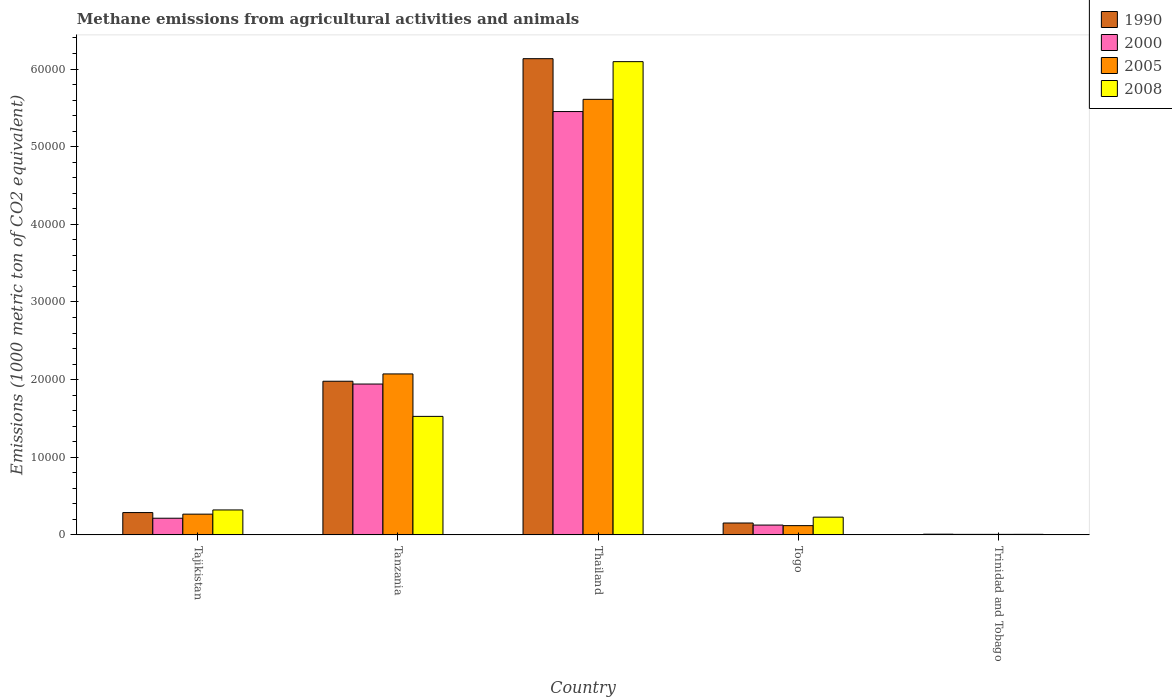Are the number of bars per tick equal to the number of legend labels?
Offer a very short reply. Yes. How many bars are there on the 1st tick from the left?
Provide a short and direct response. 4. How many bars are there on the 4th tick from the right?
Your answer should be compact. 4. What is the label of the 2nd group of bars from the left?
Your answer should be compact. Tanzania. In how many cases, is the number of bars for a given country not equal to the number of legend labels?
Provide a succinct answer. 0. What is the amount of methane emitted in 2005 in Tanzania?
Offer a terse response. 2.07e+04. Across all countries, what is the maximum amount of methane emitted in 2008?
Your response must be concise. 6.10e+04. Across all countries, what is the minimum amount of methane emitted in 2000?
Keep it short and to the point. 68. In which country was the amount of methane emitted in 2000 maximum?
Your answer should be very brief. Thailand. In which country was the amount of methane emitted in 1990 minimum?
Ensure brevity in your answer.  Trinidad and Tobago. What is the total amount of methane emitted in 2008 in the graph?
Offer a very short reply. 8.18e+04. What is the difference between the amount of methane emitted in 2000 in Tanzania and that in Trinidad and Tobago?
Your answer should be compact. 1.94e+04. What is the difference between the amount of methane emitted in 2000 in Tanzania and the amount of methane emitted in 2005 in Thailand?
Offer a very short reply. -3.67e+04. What is the average amount of methane emitted in 1990 per country?
Provide a succinct answer. 1.71e+04. What is the difference between the amount of methane emitted of/in 1990 and amount of methane emitted of/in 2000 in Tajikistan?
Offer a terse response. 727.1. What is the ratio of the amount of methane emitted in 2008 in Togo to that in Trinidad and Tobago?
Your response must be concise. 32.19. Is the amount of methane emitted in 2000 in Tajikistan less than that in Thailand?
Give a very brief answer. Yes. Is the difference between the amount of methane emitted in 1990 in Tajikistan and Thailand greater than the difference between the amount of methane emitted in 2000 in Tajikistan and Thailand?
Your response must be concise. No. What is the difference between the highest and the second highest amount of methane emitted in 2000?
Your answer should be very brief. 1.73e+04. What is the difference between the highest and the lowest amount of methane emitted in 2008?
Ensure brevity in your answer.  6.09e+04. Is the sum of the amount of methane emitted in 2000 in Tajikistan and Trinidad and Tobago greater than the maximum amount of methane emitted in 1990 across all countries?
Your answer should be compact. No. What does the 3rd bar from the left in Togo represents?
Keep it short and to the point. 2005. How many bars are there?
Your response must be concise. 20. What is the difference between two consecutive major ticks on the Y-axis?
Your answer should be very brief. 10000. Are the values on the major ticks of Y-axis written in scientific E-notation?
Offer a terse response. No. Does the graph contain grids?
Ensure brevity in your answer.  No. Where does the legend appear in the graph?
Keep it short and to the point. Top right. How are the legend labels stacked?
Ensure brevity in your answer.  Vertical. What is the title of the graph?
Keep it short and to the point. Methane emissions from agricultural activities and animals. Does "1997" appear as one of the legend labels in the graph?
Provide a succinct answer. No. What is the label or title of the X-axis?
Ensure brevity in your answer.  Country. What is the label or title of the Y-axis?
Ensure brevity in your answer.  Emissions (1000 metric ton of CO2 equivalent). What is the Emissions (1000 metric ton of CO2 equivalent) in 1990 in Tajikistan?
Give a very brief answer. 2874.3. What is the Emissions (1000 metric ton of CO2 equivalent) in 2000 in Tajikistan?
Provide a succinct answer. 2147.2. What is the Emissions (1000 metric ton of CO2 equivalent) in 2005 in Tajikistan?
Offer a terse response. 2672.7. What is the Emissions (1000 metric ton of CO2 equivalent) in 2008 in Tajikistan?
Make the answer very short. 3214.1. What is the Emissions (1000 metric ton of CO2 equivalent) of 1990 in Tanzania?
Keep it short and to the point. 1.98e+04. What is the Emissions (1000 metric ton of CO2 equivalent) in 2000 in Tanzania?
Give a very brief answer. 1.94e+04. What is the Emissions (1000 metric ton of CO2 equivalent) in 2005 in Tanzania?
Make the answer very short. 2.07e+04. What is the Emissions (1000 metric ton of CO2 equivalent) in 2008 in Tanzania?
Offer a very short reply. 1.53e+04. What is the Emissions (1000 metric ton of CO2 equivalent) of 1990 in Thailand?
Give a very brief answer. 6.13e+04. What is the Emissions (1000 metric ton of CO2 equivalent) of 2000 in Thailand?
Your answer should be very brief. 5.45e+04. What is the Emissions (1000 metric ton of CO2 equivalent) in 2005 in Thailand?
Give a very brief answer. 5.61e+04. What is the Emissions (1000 metric ton of CO2 equivalent) in 2008 in Thailand?
Give a very brief answer. 6.10e+04. What is the Emissions (1000 metric ton of CO2 equivalent) of 1990 in Togo?
Give a very brief answer. 1531.1. What is the Emissions (1000 metric ton of CO2 equivalent) in 2000 in Togo?
Keep it short and to the point. 1266.2. What is the Emissions (1000 metric ton of CO2 equivalent) in 2005 in Togo?
Your response must be concise. 1193.3. What is the Emissions (1000 metric ton of CO2 equivalent) in 2008 in Togo?
Give a very brief answer. 2285.6. What is the Emissions (1000 metric ton of CO2 equivalent) of 1990 in Trinidad and Tobago?
Your response must be concise. 92.7. What is the Emissions (1000 metric ton of CO2 equivalent) of 2000 in Trinidad and Tobago?
Provide a succinct answer. 68. What is the Emissions (1000 metric ton of CO2 equivalent) of 2005 in Trinidad and Tobago?
Your response must be concise. 68.1. Across all countries, what is the maximum Emissions (1000 metric ton of CO2 equivalent) of 1990?
Make the answer very short. 6.13e+04. Across all countries, what is the maximum Emissions (1000 metric ton of CO2 equivalent) in 2000?
Ensure brevity in your answer.  5.45e+04. Across all countries, what is the maximum Emissions (1000 metric ton of CO2 equivalent) of 2005?
Provide a short and direct response. 5.61e+04. Across all countries, what is the maximum Emissions (1000 metric ton of CO2 equivalent) of 2008?
Ensure brevity in your answer.  6.10e+04. Across all countries, what is the minimum Emissions (1000 metric ton of CO2 equivalent) in 1990?
Make the answer very short. 92.7. Across all countries, what is the minimum Emissions (1000 metric ton of CO2 equivalent) in 2000?
Your answer should be compact. 68. Across all countries, what is the minimum Emissions (1000 metric ton of CO2 equivalent) of 2005?
Provide a short and direct response. 68.1. What is the total Emissions (1000 metric ton of CO2 equivalent) in 1990 in the graph?
Ensure brevity in your answer.  8.56e+04. What is the total Emissions (1000 metric ton of CO2 equivalent) in 2000 in the graph?
Offer a terse response. 7.74e+04. What is the total Emissions (1000 metric ton of CO2 equivalent) of 2005 in the graph?
Ensure brevity in your answer.  8.08e+04. What is the total Emissions (1000 metric ton of CO2 equivalent) in 2008 in the graph?
Keep it short and to the point. 8.18e+04. What is the difference between the Emissions (1000 metric ton of CO2 equivalent) in 1990 in Tajikistan and that in Tanzania?
Make the answer very short. -1.69e+04. What is the difference between the Emissions (1000 metric ton of CO2 equivalent) in 2000 in Tajikistan and that in Tanzania?
Ensure brevity in your answer.  -1.73e+04. What is the difference between the Emissions (1000 metric ton of CO2 equivalent) in 2005 in Tajikistan and that in Tanzania?
Your response must be concise. -1.81e+04. What is the difference between the Emissions (1000 metric ton of CO2 equivalent) in 2008 in Tajikistan and that in Tanzania?
Your answer should be compact. -1.20e+04. What is the difference between the Emissions (1000 metric ton of CO2 equivalent) of 1990 in Tajikistan and that in Thailand?
Give a very brief answer. -5.85e+04. What is the difference between the Emissions (1000 metric ton of CO2 equivalent) of 2000 in Tajikistan and that in Thailand?
Ensure brevity in your answer.  -5.24e+04. What is the difference between the Emissions (1000 metric ton of CO2 equivalent) of 2005 in Tajikistan and that in Thailand?
Provide a succinct answer. -5.34e+04. What is the difference between the Emissions (1000 metric ton of CO2 equivalent) of 2008 in Tajikistan and that in Thailand?
Give a very brief answer. -5.77e+04. What is the difference between the Emissions (1000 metric ton of CO2 equivalent) of 1990 in Tajikistan and that in Togo?
Offer a terse response. 1343.2. What is the difference between the Emissions (1000 metric ton of CO2 equivalent) in 2000 in Tajikistan and that in Togo?
Your answer should be compact. 881. What is the difference between the Emissions (1000 metric ton of CO2 equivalent) of 2005 in Tajikistan and that in Togo?
Offer a very short reply. 1479.4. What is the difference between the Emissions (1000 metric ton of CO2 equivalent) of 2008 in Tajikistan and that in Togo?
Offer a very short reply. 928.5. What is the difference between the Emissions (1000 metric ton of CO2 equivalent) of 1990 in Tajikistan and that in Trinidad and Tobago?
Offer a terse response. 2781.6. What is the difference between the Emissions (1000 metric ton of CO2 equivalent) of 2000 in Tajikistan and that in Trinidad and Tobago?
Your answer should be very brief. 2079.2. What is the difference between the Emissions (1000 metric ton of CO2 equivalent) in 2005 in Tajikistan and that in Trinidad and Tobago?
Your response must be concise. 2604.6. What is the difference between the Emissions (1000 metric ton of CO2 equivalent) of 2008 in Tajikistan and that in Trinidad and Tobago?
Your response must be concise. 3143.1. What is the difference between the Emissions (1000 metric ton of CO2 equivalent) of 1990 in Tanzania and that in Thailand?
Provide a short and direct response. -4.15e+04. What is the difference between the Emissions (1000 metric ton of CO2 equivalent) in 2000 in Tanzania and that in Thailand?
Your response must be concise. -3.51e+04. What is the difference between the Emissions (1000 metric ton of CO2 equivalent) of 2005 in Tanzania and that in Thailand?
Your answer should be compact. -3.54e+04. What is the difference between the Emissions (1000 metric ton of CO2 equivalent) of 2008 in Tanzania and that in Thailand?
Ensure brevity in your answer.  -4.57e+04. What is the difference between the Emissions (1000 metric ton of CO2 equivalent) of 1990 in Tanzania and that in Togo?
Give a very brief answer. 1.83e+04. What is the difference between the Emissions (1000 metric ton of CO2 equivalent) of 2000 in Tanzania and that in Togo?
Your answer should be very brief. 1.82e+04. What is the difference between the Emissions (1000 metric ton of CO2 equivalent) in 2005 in Tanzania and that in Togo?
Your answer should be very brief. 1.95e+04. What is the difference between the Emissions (1000 metric ton of CO2 equivalent) of 2008 in Tanzania and that in Togo?
Keep it short and to the point. 1.30e+04. What is the difference between the Emissions (1000 metric ton of CO2 equivalent) of 1990 in Tanzania and that in Trinidad and Tobago?
Your response must be concise. 1.97e+04. What is the difference between the Emissions (1000 metric ton of CO2 equivalent) in 2000 in Tanzania and that in Trinidad and Tobago?
Keep it short and to the point. 1.94e+04. What is the difference between the Emissions (1000 metric ton of CO2 equivalent) in 2005 in Tanzania and that in Trinidad and Tobago?
Offer a terse response. 2.07e+04. What is the difference between the Emissions (1000 metric ton of CO2 equivalent) of 2008 in Tanzania and that in Trinidad and Tobago?
Offer a terse response. 1.52e+04. What is the difference between the Emissions (1000 metric ton of CO2 equivalent) in 1990 in Thailand and that in Togo?
Provide a short and direct response. 5.98e+04. What is the difference between the Emissions (1000 metric ton of CO2 equivalent) of 2000 in Thailand and that in Togo?
Provide a succinct answer. 5.33e+04. What is the difference between the Emissions (1000 metric ton of CO2 equivalent) in 2005 in Thailand and that in Togo?
Provide a succinct answer. 5.49e+04. What is the difference between the Emissions (1000 metric ton of CO2 equivalent) of 2008 in Thailand and that in Togo?
Make the answer very short. 5.87e+04. What is the difference between the Emissions (1000 metric ton of CO2 equivalent) of 1990 in Thailand and that in Trinidad and Tobago?
Provide a short and direct response. 6.12e+04. What is the difference between the Emissions (1000 metric ton of CO2 equivalent) of 2000 in Thailand and that in Trinidad and Tobago?
Provide a succinct answer. 5.45e+04. What is the difference between the Emissions (1000 metric ton of CO2 equivalent) in 2005 in Thailand and that in Trinidad and Tobago?
Provide a short and direct response. 5.60e+04. What is the difference between the Emissions (1000 metric ton of CO2 equivalent) in 2008 in Thailand and that in Trinidad and Tobago?
Your answer should be very brief. 6.09e+04. What is the difference between the Emissions (1000 metric ton of CO2 equivalent) of 1990 in Togo and that in Trinidad and Tobago?
Your response must be concise. 1438.4. What is the difference between the Emissions (1000 metric ton of CO2 equivalent) in 2000 in Togo and that in Trinidad and Tobago?
Keep it short and to the point. 1198.2. What is the difference between the Emissions (1000 metric ton of CO2 equivalent) of 2005 in Togo and that in Trinidad and Tobago?
Offer a very short reply. 1125.2. What is the difference between the Emissions (1000 metric ton of CO2 equivalent) of 2008 in Togo and that in Trinidad and Tobago?
Your answer should be very brief. 2214.6. What is the difference between the Emissions (1000 metric ton of CO2 equivalent) of 1990 in Tajikistan and the Emissions (1000 metric ton of CO2 equivalent) of 2000 in Tanzania?
Your answer should be very brief. -1.66e+04. What is the difference between the Emissions (1000 metric ton of CO2 equivalent) in 1990 in Tajikistan and the Emissions (1000 metric ton of CO2 equivalent) in 2005 in Tanzania?
Provide a short and direct response. -1.79e+04. What is the difference between the Emissions (1000 metric ton of CO2 equivalent) in 1990 in Tajikistan and the Emissions (1000 metric ton of CO2 equivalent) in 2008 in Tanzania?
Your answer should be very brief. -1.24e+04. What is the difference between the Emissions (1000 metric ton of CO2 equivalent) of 2000 in Tajikistan and the Emissions (1000 metric ton of CO2 equivalent) of 2005 in Tanzania?
Your response must be concise. -1.86e+04. What is the difference between the Emissions (1000 metric ton of CO2 equivalent) of 2000 in Tajikistan and the Emissions (1000 metric ton of CO2 equivalent) of 2008 in Tanzania?
Ensure brevity in your answer.  -1.31e+04. What is the difference between the Emissions (1000 metric ton of CO2 equivalent) in 2005 in Tajikistan and the Emissions (1000 metric ton of CO2 equivalent) in 2008 in Tanzania?
Keep it short and to the point. -1.26e+04. What is the difference between the Emissions (1000 metric ton of CO2 equivalent) in 1990 in Tajikistan and the Emissions (1000 metric ton of CO2 equivalent) in 2000 in Thailand?
Give a very brief answer. -5.17e+04. What is the difference between the Emissions (1000 metric ton of CO2 equivalent) of 1990 in Tajikistan and the Emissions (1000 metric ton of CO2 equivalent) of 2005 in Thailand?
Your answer should be very brief. -5.32e+04. What is the difference between the Emissions (1000 metric ton of CO2 equivalent) of 1990 in Tajikistan and the Emissions (1000 metric ton of CO2 equivalent) of 2008 in Thailand?
Provide a succinct answer. -5.81e+04. What is the difference between the Emissions (1000 metric ton of CO2 equivalent) in 2000 in Tajikistan and the Emissions (1000 metric ton of CO2 equivalent) in 2005 in Thailand?
Give a very brief answer. -5.40e+04. What is the difference between the Emissions (1000 metric ton of CO2 equivalent) of 2000 in Tajikistan and the Emissions (1000 metric ton of CO2 equivalent) of 2008 in Thailand?
Offer a very short reply. -5.88e+04. What is the difference between the Emissions (1000 metric ton of CO2 equivalent) of 2005 in Tajikistan and the Emissions (1000 metric ton of CO2 equivalent) of 2008 in Thailand?
Ensure brevity in your answer.  -5.83e+04. What is the difference between the Emissions (1000 metric ton of CO2 equivalent) of 1990 in Tajikistan and the Emissions (1000 metric ton of CO2 equivalent) of 2000 in Togo?
Keep it short and to the point. 1608.1. What is the difference between the Emissions (1000 metric ton of CO2 equivalent) of 1990 in Tajikistan and the Emissions (1000 metric ton of CO2 equivalent) of 2005 in Togo?
Give a very brief answer. 1681. What is the difference between the Emissions (1000 metric ton of CO2 equivalent) of 1990 in Tajikistan and the Emissions (1000 metric ton of CO2 equivalent) of 2008 in Togo?
Offer a very short reply. 588.7. What is the difference between the Emissions (1000 metric ton of CO2 equivalent) in 2000 in Tajikistan and the Emissions (1000 metric ton of CO2 equivalent) in 2005 in Togo?
Make the answer very short. 953.9. What is the difference between the Emissions (1000 metric ton of CO2 equivalent) in 2000 in Tajikistan and the Emissions (1000 metric ton of CO2 equivalent) in 2008 in Togo?
Keep it short and to the point. -138.4. What is the difference between the Emissions (1000 metric ton of CO2 equivalent) of 2005 in Tajikistan and the Emissions (1000 metric ton of CO2 equivalent) of 2008 in Togo?
Provide a short and direct response. 387.1. What is the difference between the Emissions (1000 metric ton of CO2 equivalent) in 1990 in Tajikistan and the Emissions (1000 metric ton of CO2 equivalent) in 2000 in Trinidad and Tobago?
Make the answer very short. 2806.3. What is the difference between the Emissions (1000 metric ton of CO2 equivalent) of 1990 in Tajikistan and the Emissions (1000 metric ton of CO2 equivalent) of 2005 in Trinidad and Tobago?
Your answer should be very brief. 2806.2. What is the difference between the Emissions (1000 metric ton of CO2 equivalent) in 1990 in Tajikistan and the Emissions (1000 metric ton of CO2 equivalent) in 2008 in Trinidad and Tobago?
Make the answer very short. 2803.3. What is the difference between the Emissions (1000 metric ton of CO2 equivalent) in 2000 in Tajikistan and the Emissions (1000 metric ton of CO2 equivalent) in 2005 in Trinidad and Tobago?
Offer a very short reply. 2079.1. What is the difference between the Emissions (1000 metric ton of CO2 equivalent) of 2000 in Tajikistan and the Emissions (1000 metric ton of CO2 equivalent) of 2008 in Trinidad and Tobago?
Your answer should be very brief. 2076.2. What is the difference between the Emissions (1000 metric ton of CO2 equivalent) in 2005 in Tajikistan and the Emissions (1000 metric ton of CO2 equivalent) in 2008 in Trinidad and Tobago?
Keep it short and to the point. 2601.7. What is the difference between the Emissions (1000 metric ton of CO2 equivalent) in 1990 in Tanzania and the Emissions (1000 metric ton of CO2 equivalent) in 2000 in Thailand?
Give a very brief answer. -3.47e+04. What is the difference between the Emissions (1000 metric ton of CO2 equivalent) of 1990 in Tanzania and the Emissions (1000 metric ton of CO2 equivalent) of 2005 in Thailand?
Your response must be concise. -3.63e+04. What is the difference between the Emissions (1000 metric ton of CO2 equivalent) in 1990 in Tanzania and the Emissions (1000 metric ton of CO2 equivalent) in 2008 in Thailand?
Your answer should be very brief. -4.12e+04. What is the difference between the Emissions (1000 metric ton of CO2 equivalent) of 2000 in Tanzania and the Emissions (1000 metric ton of CO2 equivalent) of 2005 in Thailand?
Your answer should be compact. -3.67e+04. What is the difference between the Emissions (1000 metric ton of CO2 equivalent) of 2000 in Tanzania and the Emissions (1000 metric ton of CO2 equivalent) of 2008 in Thailand?
Your answer should be very brief. -4.15e+04. What is the difference between the Emissions (1000 metric ton of CO2 equivalent) of 2005 in Tanzania and the Emissions (1000 metric ton of CO2 equivalent) of 2008 in Thailand?
Provide a succinct answer. -4.02e+04. What is the difference between the Emissions (1000 metric ton of CO2 equivalent) of 1990 in Tanzania and the Emissions (1000 metric ton of CO2 equivalent) of 2000 in Togo?
Provide a succinct answer. 1.85e+04. What is the difference between the Emissions (1000 metric ton of CO2 equivalent) of 1990 in Tanzania and the Emissions (1000 metric ton of CO2 equivalent) of 2005 in Togo?
Your answer should be very brief. 1.86e+04. What is the difference between the Emissions (1000 metric ton of CO2 equivalent) in 1990 in Tanzania and the Emissions (1000 metric ton of CO2 equivalent) in 2008 in Togo?
Offer a very short reply. 1.75e+04. What is the difference between the Emissions (1000 metric ton of CO2 equivalent) of 2000 in Tanzania and the Emissions (1000 metric ton of CO2 equivalent) of 2005 in Togo?
Offer a terse response. 1.82e+04. What is the difference between the Emissions (1000 metric ton of CO2 equivalent) in 2000 in Tanzania and the Emissions (1000 metric ton of CO2 equivalent) in 2008 in Togo?
Offer a very short reply. 1.71e+04. What is the difference between the Emissions (1000 metric ton of CO2 equivalent) in 2005 in Tanzania and the Emissions (1000 metric ton of CO2 equivalent) in 2008 in Togo?
Offer a very short reply. 1.84e+04. What is the difference between the Emissions (1000 metric ton of CO2 equivalent) of 1990 in Tanzania and the Emissions (1000 metric ton of CO2 equivalent) of 2000 in Trinidad and Tobago?
Offer a very short reply. 1.97e+04. What is the difference between the Emissions (1000 metric ton of CO2 equivalent) in 1990 in Tanzania and the Emissions (1000 metric ton of CO2 equivalent) in 2005 in Trinidad and Tobago?
Your answer should be compact. 1.97e+04. What is the difference between the Emissions (1000 metric ton of CO2 equivalent) in 1990 in Tanzania and the Emissions (1000 metric ton of CO2 equivalent) in 2008 in Trinidad and Tobago?
Your answer should be very brief. 1.97e+04. What is the difference between the Emissions (1000 metric ton of CO2 equivalent) in 2000 in Tanzania and the Emissions (1000 metric ton of CO2 equivalent) in 2005 in Trinidad and Tobago?
Your response must be concise. 1.94e+04. What is the difference between the Emissions (1000 metric ton of CO2 equivalent) in 2000 in Tanzania and the Emissions (1000 metric ton of CO2 equivalent) in 2008 in Trinidad and Tobago?
Make the answer very short. 1.94e+04. What is the difference between the Emissions (1000 metric ton of CO2 equivalent) in 2005 in Tanzania and the Emissions (1000 metric ton of CO2 equivalent) in 2008 in Trinidad and Tobago?
Give a very brief answer. 2.07e+04. What is the difference between the Emissions (1000 metric ton of CO2 equivalent) of 1990 in Thailand and the Emissions (1000 metric ton of CO2 equivalent) of 2000 in Togo?
Provide a short and direct response. 6.01e+04. What is the difference between the Emissions (1000 metric ton of CO2 equivalent) in 1990 in Thailand and the Emissions (1000 metric ton of CO2 equivalent) in 2005 in Togo?
Provide a short and direct response. 6.01e+04. What is the difference between the Emissions (1000 metric ton of CO2 equivalent) of 1990 in Thailand and the Emissions (1000 metric ton of CO2 equivalent) of 2008 in Togo?
Your answer should be compact. 5.90e+04. What is the difference between the Emissions (1000 metric ton of CO2 equivalent) in 2000 in Thailand and the Emissions (1000 metric ton of CO2 equivalent) in 2005 in Togo?
Your answer should be very brief. 5.33e+04. What is the difference between the Emissions (1000 metric ton of CO2 equivalent) of 2000 in Thailand and the Emissions (1000 metric ton of CO2 equivalent) of 2008 in Togo?
Provide a short and direct response. 5.22e+04. What is the difference between the Emissions (1000 metric ton of CO2 equivalent) in 2005 in Thailand and the Emissions (1000 metric ton of CO2 equivalent) in 2008 in Togo?
Ensure brevity in your answer.  5.38e+04. What is the difference between the Emissions (1000 metric ton of CO2 equivalent) of 1990 in Thailand and the Emissions (1000 metric ton of CO2 equivalent) of 2000 in Trinidad and Tobago?
Your response must be concise. 6.13e+04. What is the difference between the Emissions (1000 metric ton of CO2 equivalent) of 1990 in Thailand and the Emissions (1000 metric ton of CO2 equivalent) of 2005 in Trinidad and Tobago?
Provide a short and direct response. 6.13e+04. What is the difference between the Emissions (1000 metric ton of CO2 equivalent) in 1990 in Thailand and the Emissions (1000 metric ton of CO2 equivalent) in 2008 in Trinidad and Tobago?
Your answer should be compact. 6.13e+04. What is the difference between the Emissions (1000 metric ton of CO2 equivalent) in 2000 in Thailand and the Emissions (1000 metric ton of CO2 equivalent) in 2005 in Trinidad and Tobago?
Provide a succinct answer. 5.45e+04. What is the difference between the Emissions (1000 metric ton of CO2 equivalent) of 2000 in Thailand and the Emissions (1000 metric ton of CO2 equivalent) of 2008 in Trinidad and Tobago?
Offer a terse response. 5.45e+04. What is the difference between the Emissions (1000 metric ton of CO2 equivalent) in 2005 in Thailand and the Emissions (1000 metric ton of CO2 equivalent) in 2008 in Trinidad and Tobago?
Provide a succinct answer. 5.60e+04. What is the difference between the Emissions (1000 metric ton of CO2 equivalent) of 1990 in Togo and the Emissions (1000 metric ton of CO2 equivalent) of 2000 in Trinidad and Tobago?
Ensure brevity in your answer.  1463.1. What is the difference between the Emissions (1000 metric ton of CO2 equivalent) of 1990 in Togo and the Emissions (1000 metric ton of CO2 equivalent) of 2005 in Trinidad and Tobago?
Give a very brief answer. 1463. What is the difference between the Emissions (1000 metric ton of CO2 equivalent) in 1990 in Togo and the Emissions (1000 metric ton of CO2 equivalent) in 2008 in Trinidad and Tobago?
Your answer should be compact. 1460.1. What is the difference between the Emissions (1000 metric ton of CO2 equivalent) of 2000 in Togo and the Emissions (1000 metric ton of CO2 equivalent) of 2005 in Trinidad and Tobago?
Offer a very short reply. 1198.1. What is the difference between the Emissions (1000 metric ton of CO2 equivalent) in 2000 in Togo and the Emissions (1000 metric ton of CO2 equivalent) in 2008 in Trinidad and Tobago?
Give a very brief answer. 1195.2. What is the difference between the Emissions (1000 metric ton of CO2 equivalent) in 2005 in Togo and the Emissions (1000 metric ton of CO2 equivalent) in 2008 in Trinidad and Tobago?
Ensure brevity in your answer.  1122.3. What is the average Emissions (1000 metric ton of CO2 equivalent) of 1990 per country?
Your answer should be very brief. 1.71e+04. What is the average Emissions (1000 metric ton of CO2 equivalent) in 2000 per country?
Offer a terse response. 1.55e+04. What is the average Emissions (1000 metric ton of CO2 equivalent) in 2005 per country?
Provide a short and direct response. 1.62e+04. What is the average Emissions (1000 metric ton of CO2 equivalent) of 2008 per country?
Ensure brevity in your answer.  1.64e+04. What is the difference between the Emissions (1000 metric ton of CO2 equivalent) of 1990 and Emissions (1000 metric ton of CO2 equivalent) of 2000 in Tajikistan?
Provide a short and direct response. 727.1. What is the difference between the Emissions (1000 metric ton of CO2 equivalent) in 1990 and Emissions (1000 metric ton of CO2 equivalent) in 2005 in Tajikistan?
Your answer should be very brief. 201.6. What is the difference between the Emissions (1000 metric ton of CO2 equivalent) in 1990 and Emissions (1000 metric ton of CO2 equivalent) in 2008 in Tajikistan?
Offer a very short reply. -339.8. What is the difference between the Emissions (1000 metric ton of CO2 equivalent) in 2000 and Emissions (1000 metric ton of CO2 equivalent) in 2005 in Tajikistan?
Provide a succinct answer. -525.5. What is the difference between the Emissions (1000 metric ton of CO2 equivalent) in 2000 and Emissions (1000 metric ton of CO2 equivalent) in 2008 in Tajikistan?
Ensure brevity in your answer.  -1066.9. What is the difference between the Emissions (1000 metric ton of CO2 equivalent) of 2005 and Emissions (1000 metric ton of CO2 equivalent) of 2008 in Tajikistan?
Offer a very short reply. -541.4. What is the difference between the Emissions (1000 metric ton of CO2 equivalent) of 1990 and Emissions (1000 metric ton of CO2 equivalent) of 2000 in Tanzania?
Provide a succinct answer. 358.8. What is the difference between the Emissions (1000 metric ton of CO2 equivalent) of 1990 and Emissions (1000 metric ton of CO2 equivalent) of 2005 in Tanzania?
Give a very brief answer. -942.8. What is the difference between the Emissions (1000 metric ton of CO2 equivalent) in 1990 and Emissions (1000 metric ton of CO2 equivalent) in 2008 in Tanzania?
Provide a short and direct response. 4525.2. What is the difference between the Emissions (1000 metric ton of CO2 equivalent) in 2000 and Emissions (1000 metric ton of CO2 equivalent) in 2005 in Tanzania?
Your answer should be compact. -1301.6. What is the difference between the Emissions (1000 metric ton of CO2 equivalent) of 2000 and Emissions (1000 metric ton of CO2 equivalent) of 2008 in Tanzania?
Make the answer very short. 4166.4. What is the difference between the Emissions (1000 metric ton of CO2 equivalent) of 2005 and Emissions (1000 metric ton of CO2 equivalent) of 2008 in Tanzania?
Your answer should be compact. 5468. What is the difference between the Emissions (1000 metric ton of CO2 equivalent) of 1990 and Emissions (1000 metric ton of CO2 equivalent) of 2000 in Thailand?
Offer a terse response. 6808.4. What is the difference between the Emissions (1000 metric ton of CO2 equivalent) in 1990 and Emissions (1000 metric ton of CO2 equivalent) in 2005 in Thailand?
Your response must be concise. 5235.2. What is the difference between the Emissions (1000 metric ton of CO2 equivalent) of 1990 and Emissions (1000 metric ton of CO2 equivalent) of 2008 in Thailand?
Your response must be concise. 381.9. What is the difference between the Emissions (1000 metric ton of CO2 equivalent) of 2000 and Emissions (1000 metric ton of CO2 equivalent) of 2005 in Thailand?
Offer a terse response. -1573.2. What is the difference between the Emissions (1000 metric ton of CO2 equivalent) in 2000 and Emissions (1000 metric ton of CO2 equivalent) in 2008 in Thailand?
Your answer should be compact. -6426.5. What is the difference between the Emissions (1000 metric ton of CO2 equivalent) of 2005 and Emissions (1000 metric ton of CO2 equivalent) of 2008 in Thailand?
Your response must be concise. -4853.3. What is the difference between the Emissions (1000 metric ton of CO2 equivalent) of 1990 and Emissions (1000 metric ton of CO2 equivalent) of 2000 in Togo?
Make the answer very short. 264.9. What is the difference between the Emissions (1000 metric ton of CO2 equivalent) in 1990 and Emissions (1000 metric ton of CO2 equivalent) in 2005 in Togo?
Keep it short and to the point. 337.8. What is the difference between the Emissions (1000 metric ton of CO2 equivalent) in 1990 and Emissions (1000 metric ton of CO2 equivalent) in 2008 in Togo?
Your answer should be very brief. -754.5. What is the difference between the Emissions (1000 metric ton of CO2 equivalent) in 2000 and Emissions (1000 metric ton of CO2 equivalent) in 2005 in Togo?
Make the answer very short. 72.9. What is the difference between the Emissions (1000 metric ton of CO2 equivalent) of 2000 and Emissions (1000 metric ton of CO2 equivalent) of 2008 in Togo?
Your answer should be very brief. -1019.4. What is the difference between the Emissions (1000 metric ton of CO2 equivalent) in 2005 and Emissions (1000 metric ton of CO2 equivalent) in 2008 in Togo?
Your answer should be very brief. -1092.3. What is the difference between the Emissions (1000 metric ton of CO2 equivalent) of 1990 and Emissions (1000 metric ton of CO2 equivalent) of 2000 in Trinidad and Tobago?
Ensure brevity in your answer.  24.7. What is the difference between the Emissions (1000 metric ton of CO2 equivalent) in 1990 and Emissions (1000 metric ton of CO2 equivalent) in 2005 in Trinidad and Tobago?
Offer a very short reply. 24.6. What is the difference between the Emissions (1000 metric ton of CO2 equivalent) of 1990 and Emissions (1000 metric ton of CO2 equivalent) of 2008 in Trinidad and Tobago?
Ensure brevity in your answer.  21.7. What is the difference between the Emissions (1000 metric ton of CO2 equivalent) of 2000 and Emissions (1000 metric ton of CO2 equivalent) of 2008 in Trinidad and Tobago?
Provide a succinct answer. -3. What is the ratio of the Emissions (1000 metric ton of CO2 equivalent) of 1990 in Tajikistan to that in Tanzania?
Provide a succinct answer. 0.15. What is the ratio of the Emissions (1000 metric ton of CO2 equivalent) of 2000 in Tajikistan to that in Tanzania?
Your response must be concise. 0.11. What is the ratio of the Emissions (1000 metric ton of CO2 equivalent) in 2005 in Tajikistan to that in Tanzania?
Give a very brief answer. 0.13. What is the ratio of the Emissions (1000 metric ton of CO2 equivalent) in 2008 in Tajikistan to that in Tanzania?
Provide a short and direct response. 0.21. What is the ratio of the Emissions (1000 metric ton of CO2 equivalent) in 1990 in Tajikistan to that in Thailand?
Ensure brevity in your answer.  0.05. What is the ratio of the Emissions (1000 metric ton of CO2 equivalent) in 2000 in Tajikistan to that in Thailand?
Offer a very short reply. 0.04. What is the ratio of the Emissions (1000 metric ton of CO2 equivalent) in 2005 in Tajikistan to that in Thailand?
Offer a very short reply. 0.05. What is the ratio of the Emissions (1000 metric ton of CO2 equivalent) in 2008 in Tajikistan to that in Thailand?
Your response must be concise. 0.05. What is the ratio of the Emissions (1000 metric ton of CO2 equivalent) of 1990 in Tajikistan to that in Togo?
Your response must be concise. 1.88. What is the ratio of the Emissions (1000 metric ton of CO2 equivalent) of 2000 in Tajikistan to that in Togo?
Your response must be concise. 1.7. What is the ratio of the Emissions (1000 metric ton of CO2 equivalent) in 2005 in Tajikistan to that in Togo?
Provide a short and direct response. 2.24. What is the ratio of the Emissions (1000 metric ton of CO2 equivalent) in 2008 in Tajikistan to that in Togo?
Keep it short and to the point. 1.41. What is the ratio of the Emissions (1000 metric ton of CO2 equivalent) of 1990 in Tajikistan to that in Trinidad and Tobago?
Offer a terse response. 31.01. What is the ratio of the Emissions (1000 metric ton of CO2 equivalent) in 2000 in Tajikistan to that in Trinidad and Tobago?
Offer a very short reply. 31.58. What is the ratio of the Emissions (1000 metric ton of CO2 equivalent) in 2005 in Tajikistan to that in Trinidad and Tobago?
Keep it short and to the point. 39.25. What is the ratio of the Emissions (1000 metric ton of CO2 equivalent) of 2008 in Tajikistan to that in Trinidad and Tobago?
Your answer should be compact. 45.27. What is the ratio of the Emissions (1000 metric ton of CO2 equivalent) in 1990 in Tanzania to that in Thailand?
Your answer should be compact. 0.32. What is the ratio of the Emissions (1000 metric ton of CO2 equivalent) of 2000 in Tanzania to that in Thailand?
Make the answer very short. 0.36. What is the ratio of the Emissions (1000 metric ton of CO2 equivalent) of 2005 in Tanzania to that in Thailand?
Your answer should be compact. 0.37. What is the ratio of the Emissions (1000 metric ton of CO2 equivalent) of 2008 in Tanzania to that in Thailand?
Offer a very short reply. 0.25. What is the ratio of the Emissions (1000 metric ton of CO2 equivalent) of 1990 in Tanzania to that in Togo?
Your response must be concise. 12.92. What is the ratio of the Emissions (1000 metric ton of CO2 equivalent) in 2000 in Tanzania to that in Togo?
Offer a very short reply. 15.35. What is the ratio of the Emissions (1000 metric ton of CO2 equivalent) of 2005 in Tanzania to that in Togo?
Your answer should be compact. 17.37. What is the ratio of the Emissions (1000 metric ton of CO2 equivalent) of 2008 in Tanzania to that in Togo?
Your answer should be compact. 6.68. What is the ratio of the Emissions (1000 metric ton of CO2 equivalent) in 1990 in Tanzania to that in Trinidad and Tobago?
Your answer should be very brief. 213.47. What is the ratio of the Emissions (1000 metric ton of CO2 equivalent) of 2000 in Tanzania to that in Trinidad and Tobago?
Offer a very short reply. 285.73. What is the ratio of the Emissions (1000 metric ton of CO2 equivalent) in 2005 in Tanzania to that in Trinidad and Tobago?
Offer a very short reply. 304.43. What is the ratio of the Emissions (1000 metric ton of CO2 equivalent) of 2008 in Tanzania to that in Trinidad and Tobago?
Your response must be concise. 214.98. What is the ratio of the Emissions (1000 metric ton of CO2 equivalent) of 1990 in Thailand to that in Togo?
Your response must be concise. 40.06. What is the ratio of the Emissions (1000 metric ton of CO2 equivalent) of 2000 in Thailand to that in Togo?
Make the answer very short. 43.06. What is the ratio of the Emissions (1000 metric ton of CO2 equivalent) of 2005 in Thailand to that in Togo?
Ensure brevity in your answer.  47.01. What is the ratio of the Emissions (1000 metric ton of CO2 equivalent) of 2008 in Thailand to that in Togo?
Offer a terse response. 26.67. What is the ratio of the Emissions (1000 metric ton of CO2 equivalent) of 1990 in Thailand to that in Trinidad and Tobago?
Make the answer very short. 661.63. What is the ratio of the Emissions (1000 metric ton of CO2 equivalent) in 2000 in Thailand to that in Trinidad and Tobago?
Offer a terse response. 801.84. What is the ratio of the Emissions (1000 metric ton of CO2 equivalent) of 2005 in Thailand to that in Trinidad and Tobago?
Provide a short and direct response. 823.76. What is the ratio of the Emissions (1000 metric ton of CO2 equivalent) in 2008 in Thailand to that in Trinidad and Tobago?
Your answer should be compact. 858.47. What is the ratio of the Emissions (1000 metric ton of CO2 equivalent) in 1990 in Togo to that in Trinidad and Tobago?
Provide a short and direct response. 16.52. What is the ratio of the Emissions (1000 metric ton of CO2 equivalent) of 2000 in Togo to that in Trinidad and Tobago?
Provide a succinct answer. 18.62. What is the ratio of the Emissions (1000 metric ton of CO2 equivalent) in 2005 in Togo to that in Trinidad and Tobago?
Your answer should be very brief. 17.52. What is the ratio of the Emissions (1000 metric ton of CO2 equivalent) in 2008 in Togo to that in Trinidad and Tobago?
Your answer should be compact. 32.19. What is the difference between the highest and the second highest Emissions (1000 metric ton of CO2 equivalent) in 1990?
Give a very brief answer. 4.15e+04. What is the difference between the highest and the second highest Emissions (1000 metric ton of CO2 equivalent) of 2000?
Make the answer very short. 3.51e+04. What is the difference between the highest and the second highest Emissions (1000 metric ton of CO2 equivalent) of 2005?
Your answer should be compact. 3.54e+04. What is the difference between the highest and the second highest Emissions (1000 metric ton of CO2 equivalent) of 2008?
Keep it short and to the point. 4.57e+04. What is the difference between the highest and the lowest Emissions (1000 metric ton of CO2 equivalent) of 1990?
Your response must be concise. 6.12e+04. What is the difference between the highest and the lowest Emissions (1000 metric ton of CO2 equivalent) in 2000?
Give a very brief answer. 5.45e+04. What is the difference between the highest and the lowest Emissions (1000 metric ton of CO2 equivalent) of 2005?
Your answer should be very brief. 5.60e+04. What is the difference between the highest and the lowest Emissions (1000 metric ton of CO2 equivalent) in 2008?
Make the answer very short. 6.09e+04. 